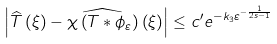<formula> <loc_0><loc_0><loc_500><loc_500>\left | \widehat { T } \left ( \xi \right ) - \widehat { \chi \left ( T \ast \phi _ { \varepsilon } \right ) } \left ( \xi \right ) \right | \leq c ^ { \prime } e ^ { - k _ { 3 } \varepsilon ^ { - \frac { 1 } { 2 s - 1 } } }</formula> 